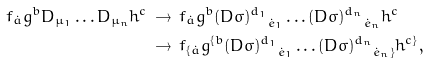<formula> <loc_0><loc_0><loc_500><loc_500>f _ { \dot { a } } g ^ { b } D _ { \mu _ { 1 } } \dots D _ { \mu _ { n } } h ^ { c } \, & \to \, f _ { \dot { a } } g ^ { b } { ( D \sigma ) ^ { d _ { 1 } } } _ { \dot { e } _ { 1 } } \dots { ( D \sigma ) ^ { d _ { n } } } _ { \dot { e } _ { n } } h ^ { c } \, \\ & \to \, f _ { \{ \dot { a } } g ^ { \{ b } { ( D \sigma ) ^ { d _ { 1 } } } _ { \dot { e } _ { 1 } } \dots { ( D \sigma ) ^ { d _ { n } } } _ { \dot { e } _ { n } \} } h ^ { c \} } ,</formula> 